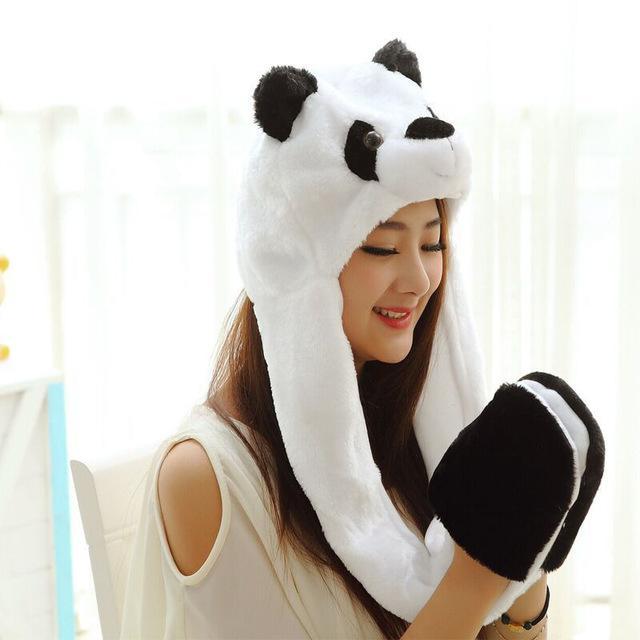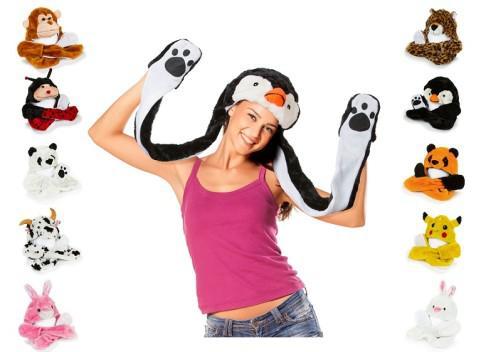The first image is the image on the left, the second image is the image on the right. Considering the images on both sides, is "The person in the image on the left is wearing a hat that looks like a bear." valid? Answer yes or no. Yes. 